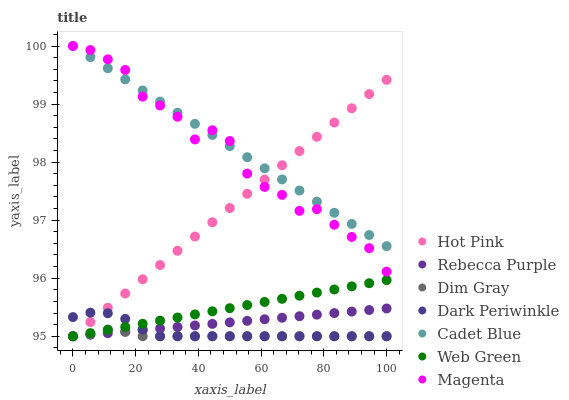Does Dim Gray have the minimum area under the curve?
Answer yes or no. Yes. Does Cadet Blue have the maximum area under the curve?
Answer yes or no. Yes. Does Hot Pink have the minimum area under the curve?
Answer yes or no. No. Does Hot Pink have the maximum area under the curve?
Answer yes or no. No. Is Hot Pink the smoothest?
Answer yes or no. Yes. Is Magenta the roughest?
Answer yes or no. Yes. Is Web Green the smoothest?
Answer yes or no. No. Is Web Green the roughest?
Answer yes or no. No. Does Hot Pink have the lowest value?
Answer yes or no. Yes. Does Magenta have the lowest value?
Answer yes or no. No. Does Magenta have the highest value?
Answer yes or no. Yes. Does Hot Pink have the highest value?
Answer yes or no. No. Is Web Green less than Cadet Blue?
Answer yes or no. Yes. Is Magenta greater than Rebecca Purple?
Answer yes or no. Yes. Does Web Green intersect Dark Periwinkle?
Answer yes or no. Yes. Is Web Green less than Dark Periwinkle?
Answer yes or no. No. Is Web Green greater than Dark Periwinkle?
Answer yes or no. No. Does Web Green intersect Cadet Blue?
Answer yes or no. No. 